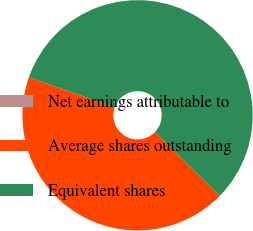Convert chart to OTSL. <chart><loc_0><loc_0><loc_500><loc_500><pie_chart><fcel>Net earnings attributable to<fcel>Average shares outstanding<fcel>Equivalent shares<nl><fcel>0.0%<fcel>43.03%<fcel>56.97%<nl></chart> 